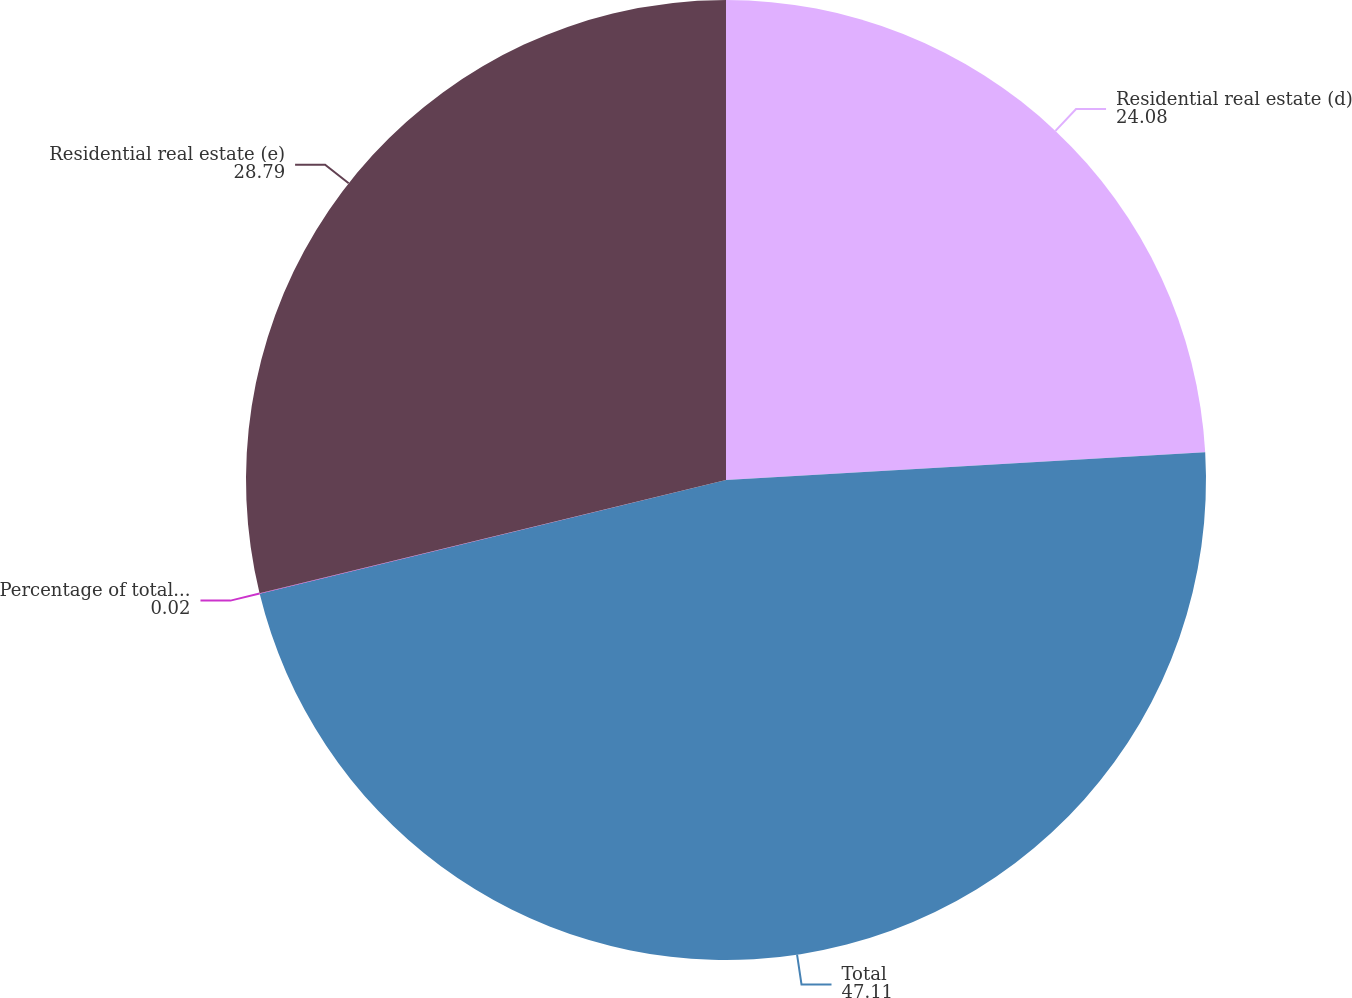Convert chart to OTSL. <chart><loc_0><loc_0><loc_500><loc_500><pie_chart><fcel>Residential real estate (d)<fcel>Total<fcel>Percentage of total loans<fcel>Residential real estate (e)<nl><fcel>24.08%<fcel>47.11%<fcel>0.02%<fcel>28.79%<nl></chart> 